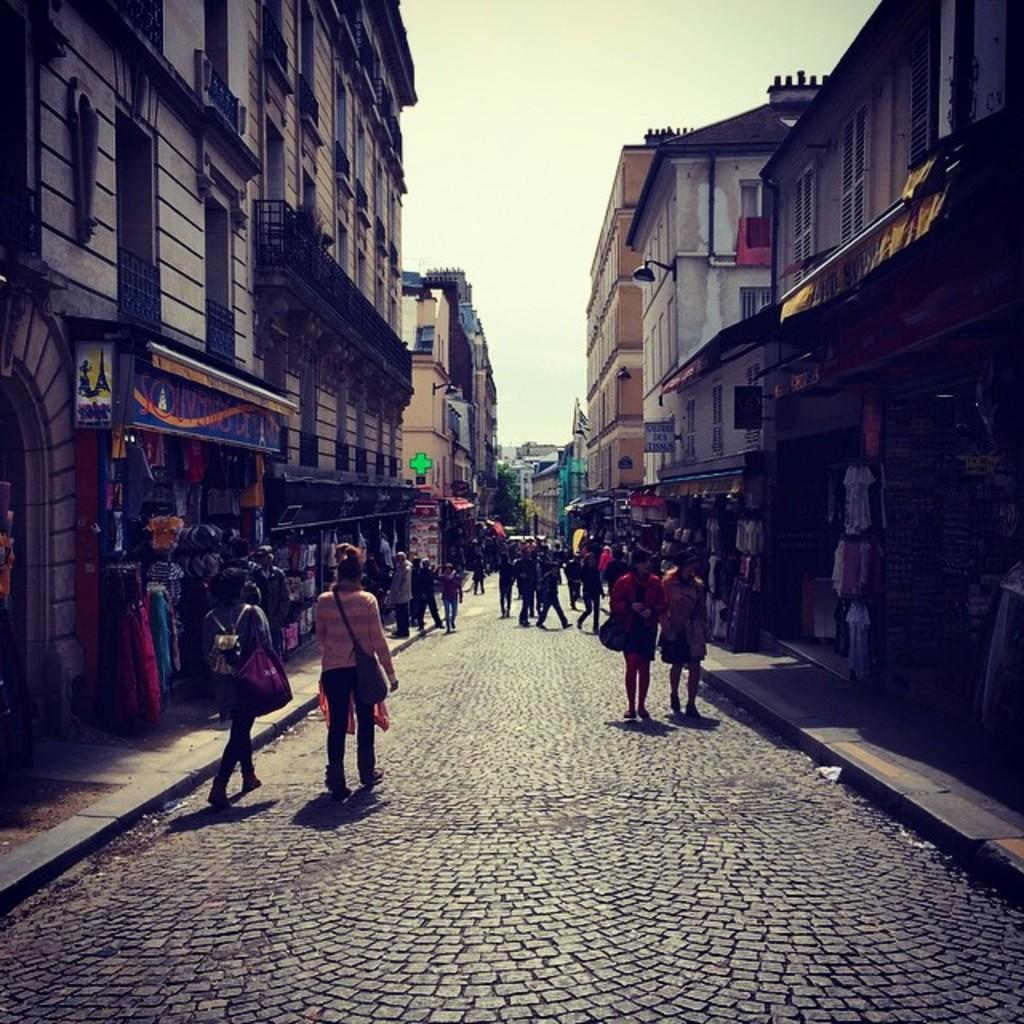Describe this image in one or two sentences. In this image there are a few people walking on the streets, beside the streets on the pavement there are buildings, in front of the buildings there are stalls with name boards on it, in the background of the image there are trees. 